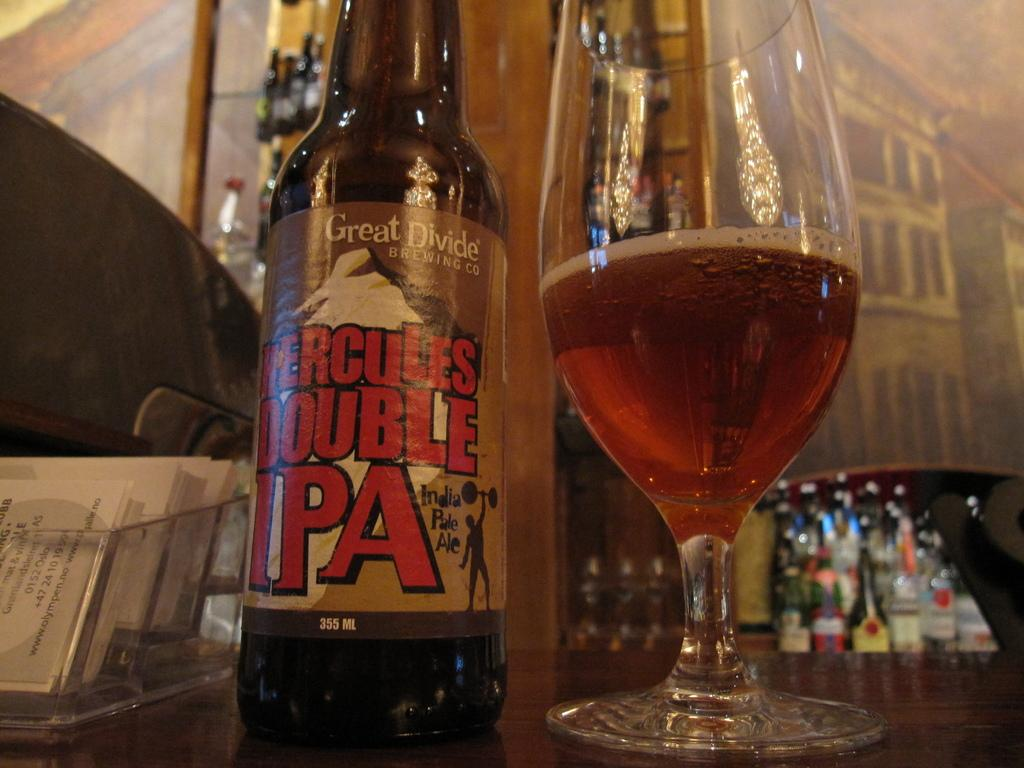What objects are on the table in the image? There are books, a bottle, and a glass on the table in the image. Can you describe the bottle on the table? The bottle on the table is an unspecified type of bottle. What might be used for drinking in the image? The glass on the table might be used for drinking. What type of match is being used to light the candle on the table? There is no candle present in the image, so it is not possible to determine if a match is being used or not. 